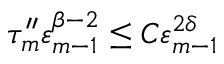<formula> <loc_0><loc_0><loc_500><loc_500>\tau _ { m } ^ { \prime \prime } \varepsilon _ { m - 1 } ^ { \beta - 2 } \leq C \varepsilon _ { m - 1 } ^ { 2 \delta }</formula> 